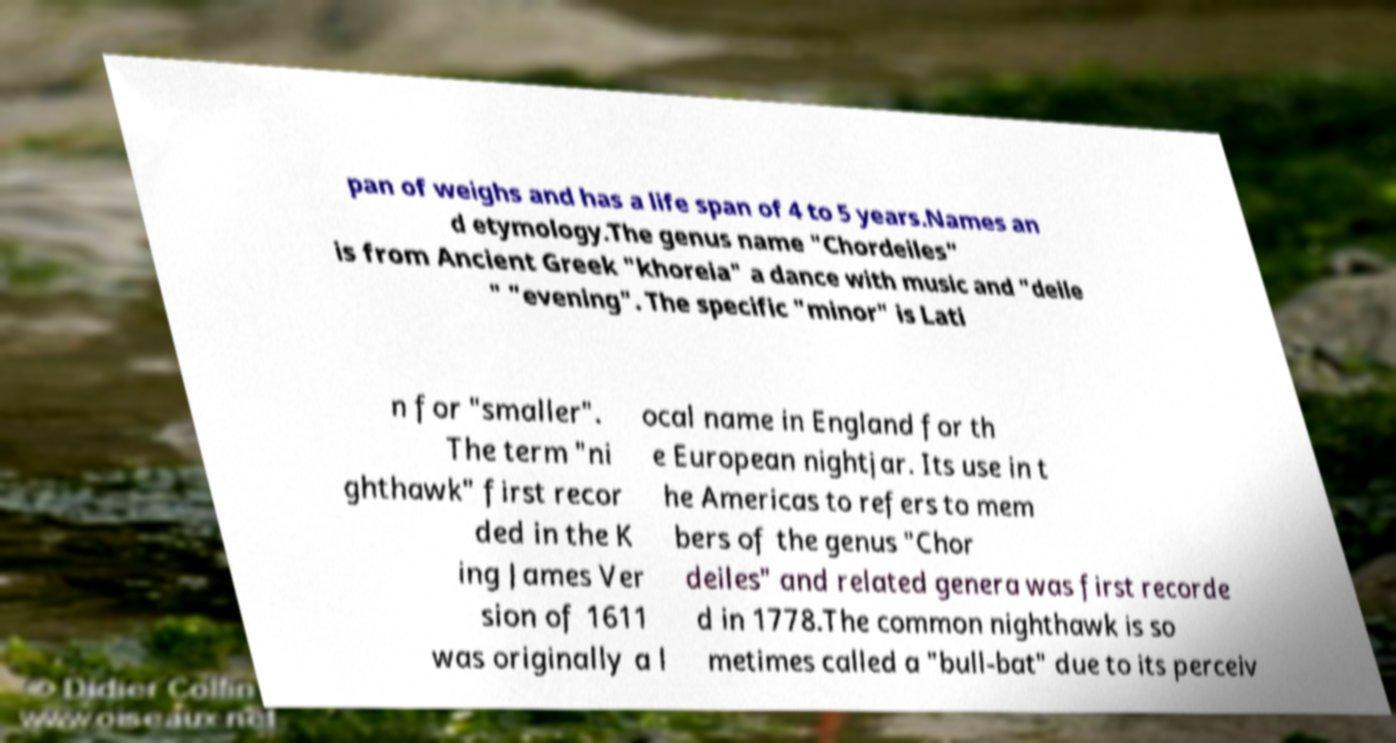Please identify and transcribe the text found in this image. pan of weighs and has a life span of 4 to 5 years.Names an d etymology.The genus name "Chordeiles" is from Ancient Greek "khoreia" a dance with music and "deile " "evening". The specific "minor" is Lati n for "smaller". The term "ni ghthawk" first recor ded in the K ing James Ver sion of 1611 was originally a l ocal name in England for th e European nightjar. Its use in t he Americas to refers to mem bers of the genus "Chor deiles" and related genera was first recorde d in 1778.The common nighthawk is so metimes called a "bull-bat" due to its perceiv 